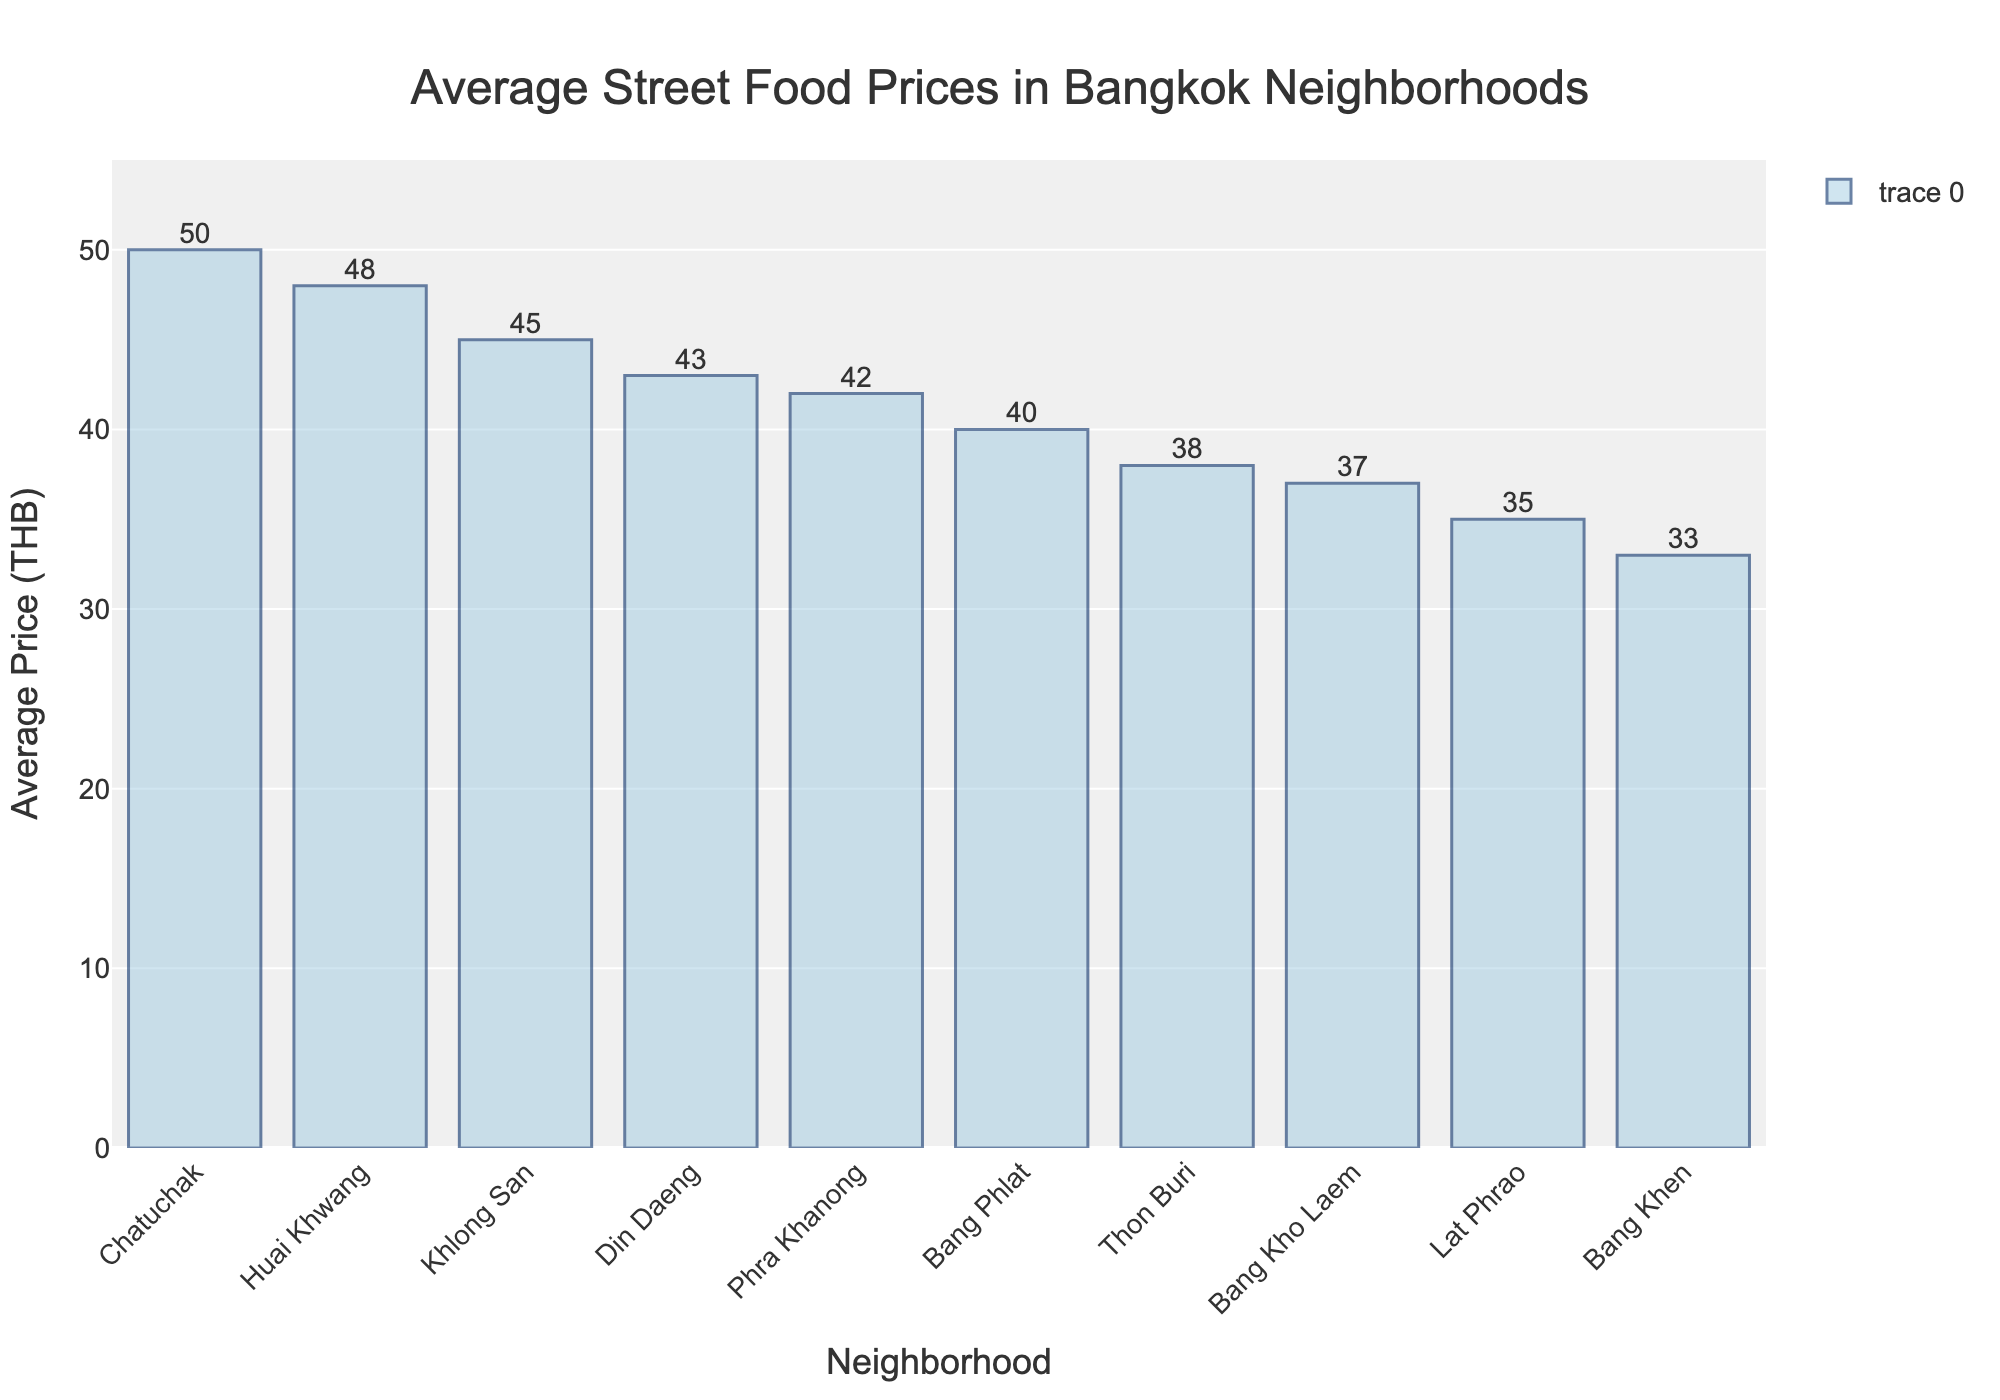Which neighborhood has the highest average street food price? By looking at the highest bar in the chart, we can see that "Chatuchak" has the topmost bar.
Answer: Chatuchak How much more expensive is the average street food in Huai Khwang compared to Lat Phrao? By reading the heights of the bars for "Huai Khwang" and "Lat Phrao," we subtract the average price of Lat Phrao (35 THB) from Huai Khwang (48 THB). The difference is 48 - 35 = 13 THB.
Answer: 13 THB Which two neighborhoods have the lowest average street food prices? By identifying the two shortest bars in the chart, we see that "Bang Khen" and "Lat Phrao" are the two neighborhoods with the lowest average prices.
Answer: Bang Khen and Lat Phrao What is the average price of street food in all the neighborhoods combined? Adding all the average prices (45 + 40 + 38 + 42 + 35 + 37 + 50 + 43 + 48 + 33) gives a total of 411 THB. Dividing by the number of neighborhoods (10) gives an average of 411/10 = 41.1 THB.
Answer: 41.1 THB Which neighborhood's average street food price is closest to the overall average price? From the previous calculation, the overall average price is 41.1 THB. Evaluating the difference from the overall average for each neighborhood: Khlong San (45 - 41.1 = 3.9), Bang Phlat (40 - 41.1 = 1.1), etc. "Bang Phlat" with a difference of 1.1 is the closest.
Answer: Bang Phlat How many neighborhoods have an average street food price below 40 THB? By counting the bars with heights below the 40 THB mark, we find "Lat Phrao," "Bang Kho Laem," "Bang Khen," and "Thon Buri." This totals 4 neighborhoods.
Answer: 4 Is there a larger difference between the highest and lowest average street food prices or between Chatuchak and Huai Khwang? The difference between the highest (Chatuchak, 50 THB) and the lowest (Bang Khen, 33 THB) is 50 - 33 = 17 THB. The difference between Chatuchak (50 THB) and Huai Khwang (48 THB) is 50 - 48 = 2 THB. The first difference is larger.
Answer: Highest and lowest Arrange the neighborhoods in descending order of their average street food prices. Observing the lengths of the bars from tallest to shortest, the order is: Chatuchak, Huai Khwang, Khlong San, Din Daeng, Phra Khanong, Bang Phlat, Thon Buri, Bang Kho Laem, Lat Phrao, Bang Khen.
Answer: Chatuchak, Huai Khwang, Khlong San, Din Daeng, Phra Khanong, Bang Phlat, Thon Buri, Bang Kho Laem, Lat Phrao, Bang Khen 